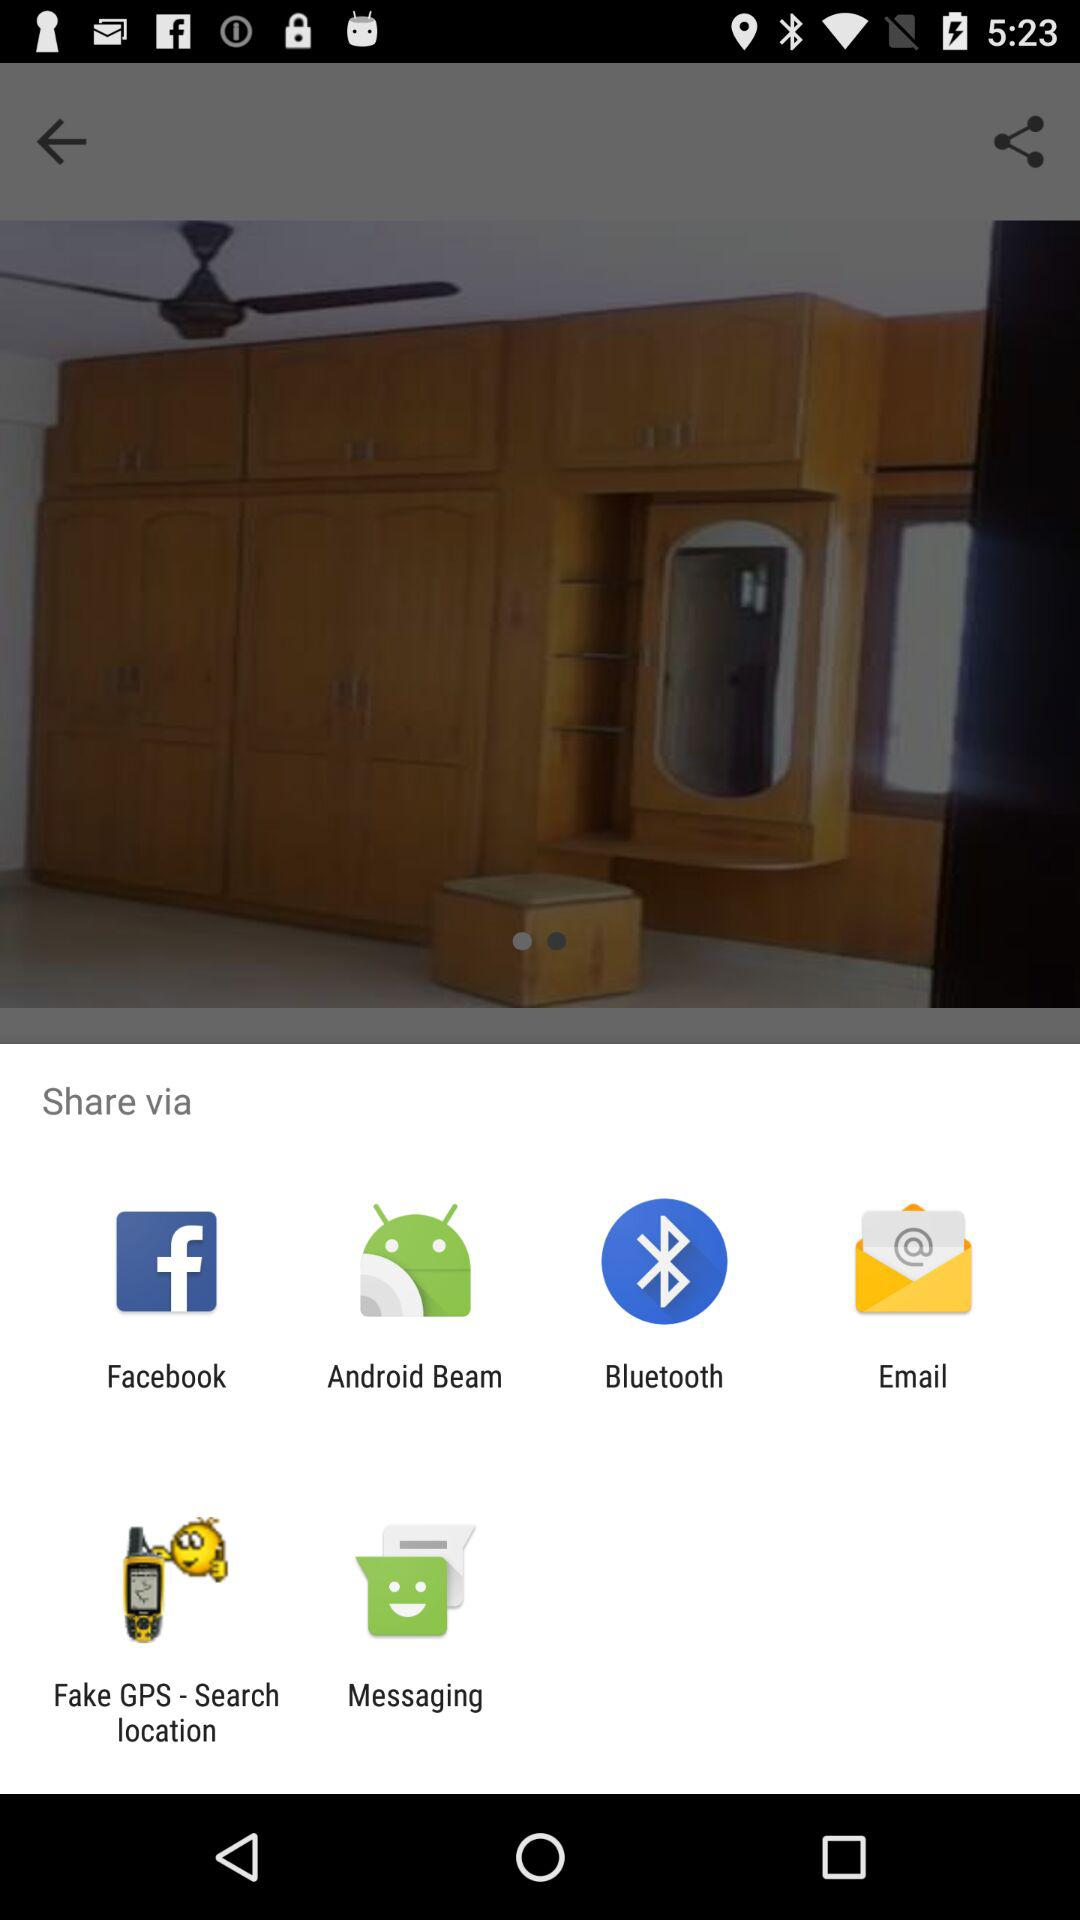Through which application can we share? You can share through "Facebook", "Android Beam", "Bluetooth", "Email", "Fake GPS - Search location" and "Messaging". 